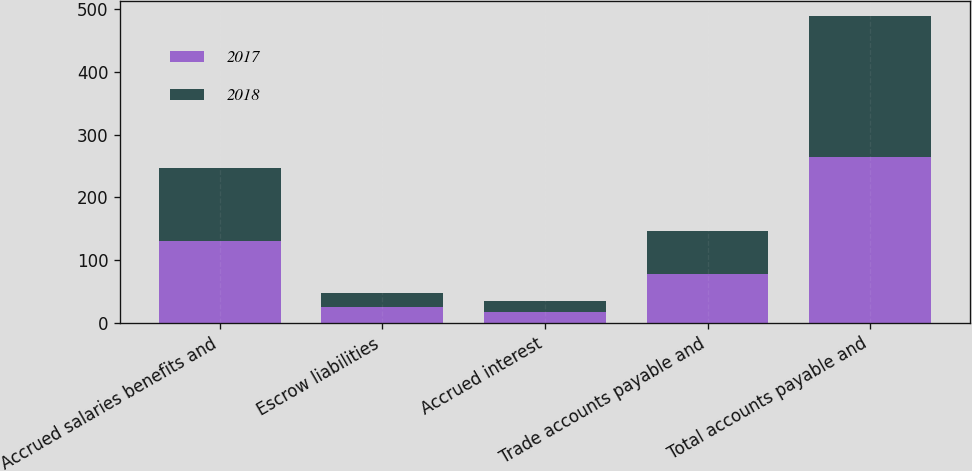Convert chart. <chart><loc_0><loc_0><loc_500><loc_500><stacked_bar_chart><ecel><fcel>Accrued salaries benefits and<fcel>Escrow liabilities<fcel>Accrued interest<fcel>Trade accounts payable and<fcel>Total accounts payable and<nl><fcel>2017<fcel>131.1<fcel>25.4<fcel>17.2<fcel>77.2<fcel>263.5<nl><fcel>2018<fcel>115.3<fcel>22.9<fcel>18.3<fcel>68.9<fcel>225.4<nl></chart> 